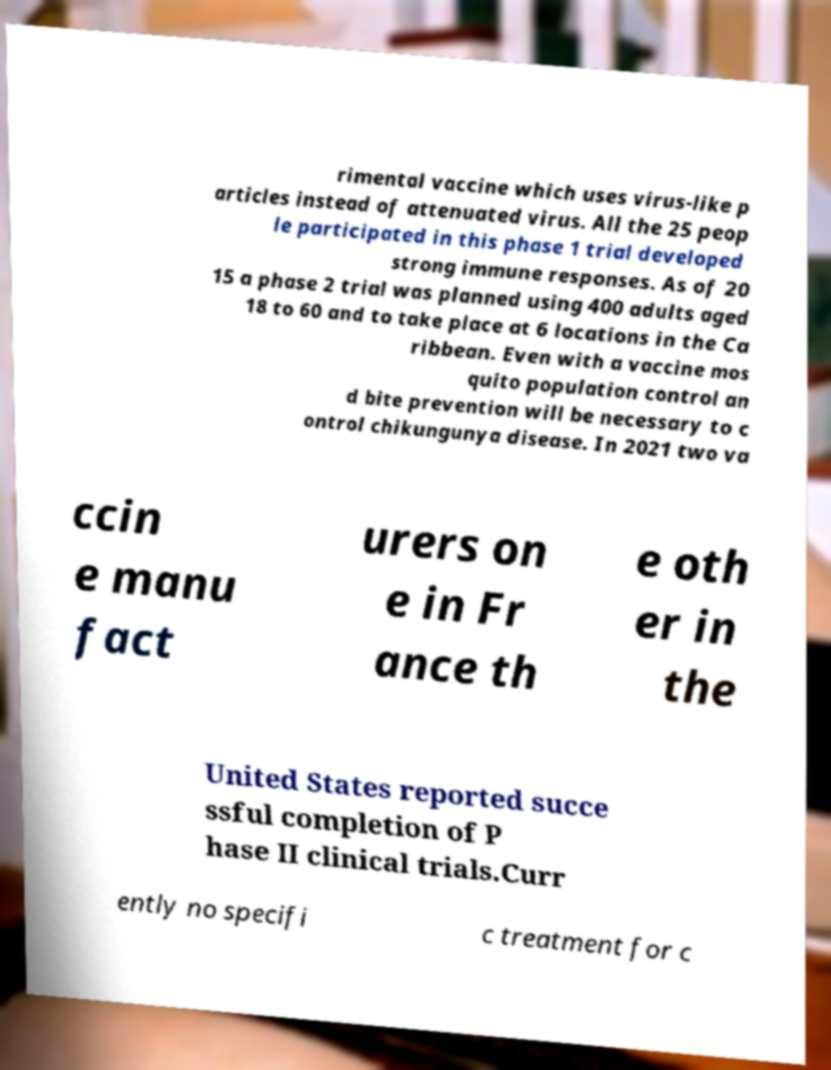Please read and relay the text visible in this image. What does it say? rimental vaccine which uses virus-like p articles instead of attenuated virus. All the 25 peop le participated in this phase 1 trial developed strong immune responses. As of 20 15 a phase 2 trial was planned using 400 adults aged 18 to 60 and to take place at 6 locations in the Ca ribbean. Even with a vaccine mos quito population control an d bite prevention will be necessary to c ontrol chikungunya disease. In 2021 two va ccin e manu fact urers on e in Fr ance th e oth er in the United States reported succe ssful completion of P hase II clinical trials.Curr ently no specifi c treatment for c 